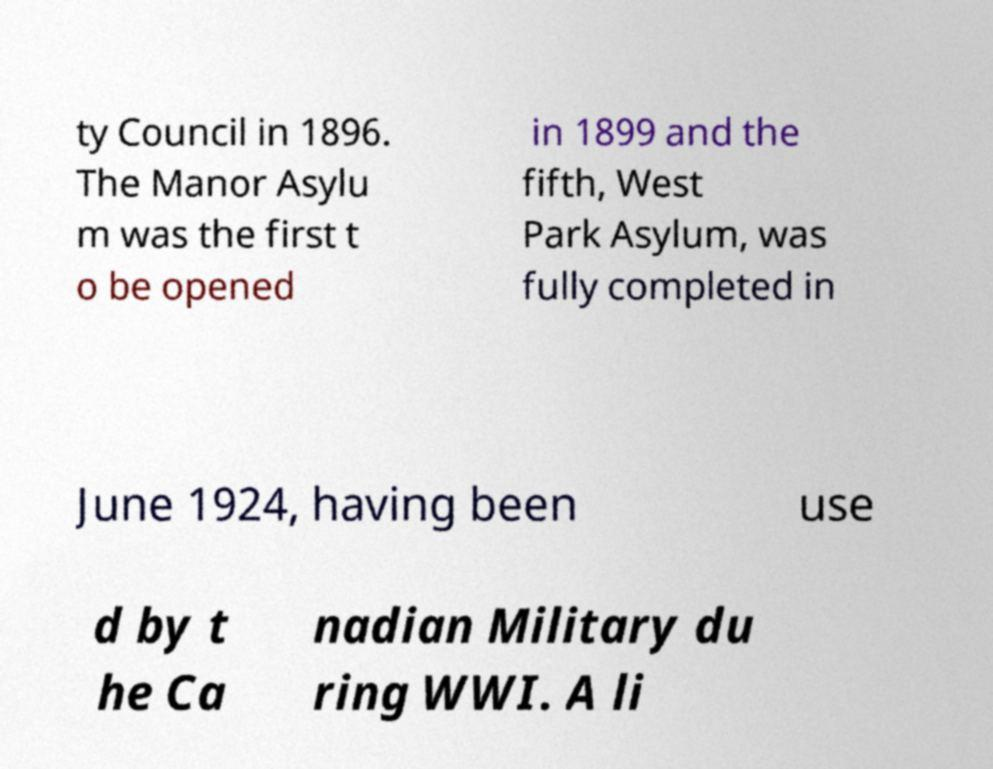Please identify and transcribe the text found in this image. ty Council in 1896. The Manor Asylu m was the first t o be opened in 1899 and the fifth, West Park Asylum, was fully completed in June 1924, having been use d by t he Ca nadian Military du ring WWI. A li 